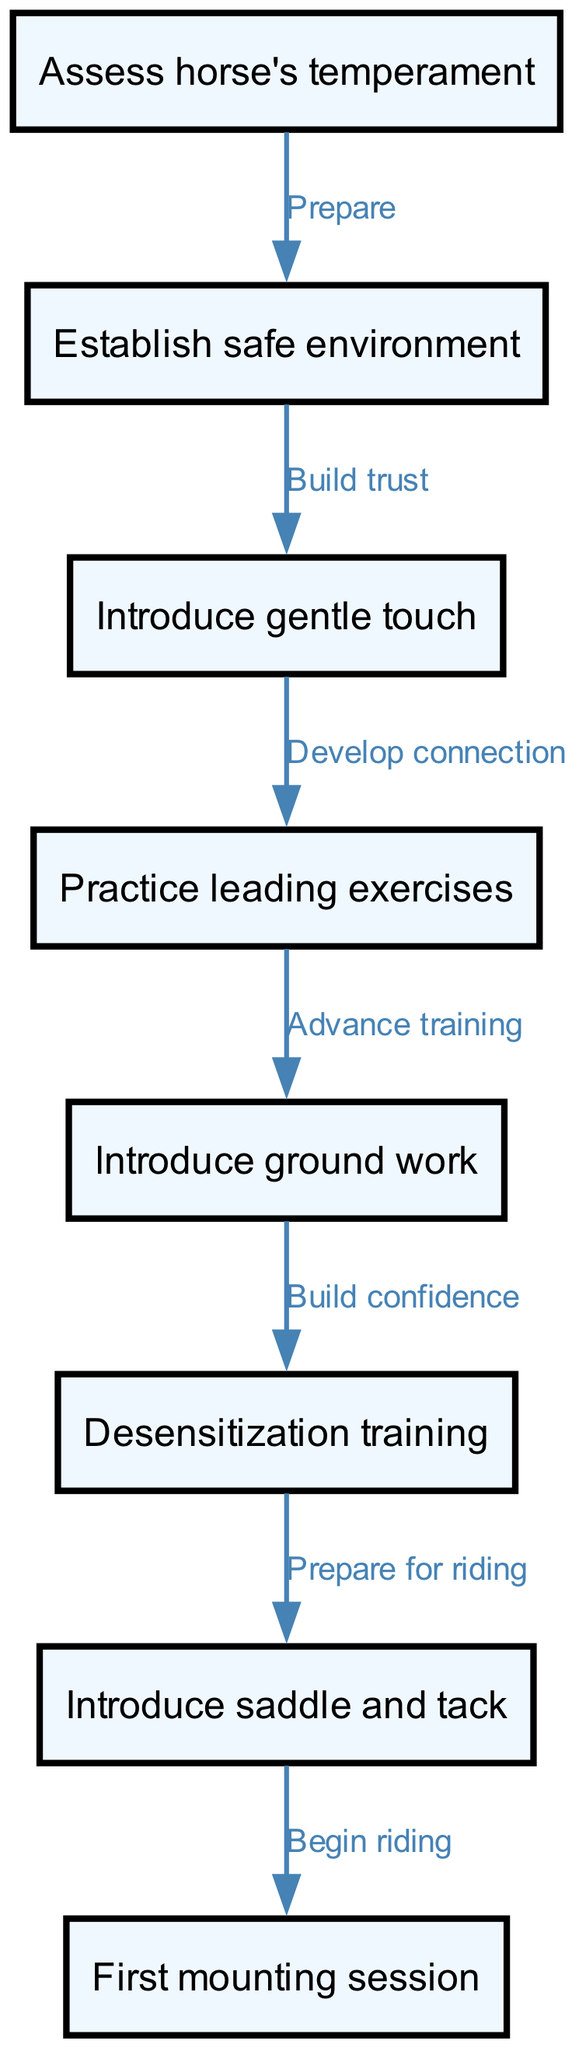What is the first step in the training process? The first step in the training process is located at node 1, which is "Assess horse's temperament". This is the starting point of the flowchart indicating where the process begins.
Answer: Assess horse's temperament How many nodes are in the diagram? The diagram has a total of 8 nodes representing different steps in the training process. By counting each node listed, we find that there are eight distinct nodes.
Answer: 8 What is the relationship between "Establish safe environment" and "Introduce gentle touch"? The relationship is indicated by the edge connecting node 2 (Establish safe environment) to node 3 (Introduce gentle touch), labeled as "Build trust". This shows that after establishing a safe environment, the next step is to build trust through gentle touch.
Answer: Build trust What step follows "Desensitization training"? The step that follows "Desensitization training" is represented by node 7, which is "Introduce saddle and tack". The flow of the diagram shows the progression from desensitization training to getting the horse accustomed to the saddle and tack.
Answer: Introduce saddle and tack How many edges are there in total? There are 7 edges in the flowchart, with each edge representing a connection or transition between steps in the training process. By counting each edge presented, we find a total of seven connections linking the nodes.
Answer: 7 What is the label on the edge from "Introduce ground work" to "Desensitization training"? The label on the edge connecting node 5 (Introduce ground work) to node 6 (Desensitization training) is "Build confidence". This indicates the purpose of transitioning to desensitization training after groundwork is established.
Answer: Build confidence What step comes after "First mounting session"? The flowchart does not depict any further steps after "First mounting session", indicating it is the final step in the training process. There are no additional actions connecting from this node, making it the endpoint.
Answer: [None] What technique is introduced after practicing leading exercises? After practicing leading exercises (node 4), the next technique introduced is "Introduce ground work" (node 5). This shows the sequential progression in the training process as the horse becomes accustomed to leading before advancing to groundwork.
Answer: Introduce ground work 